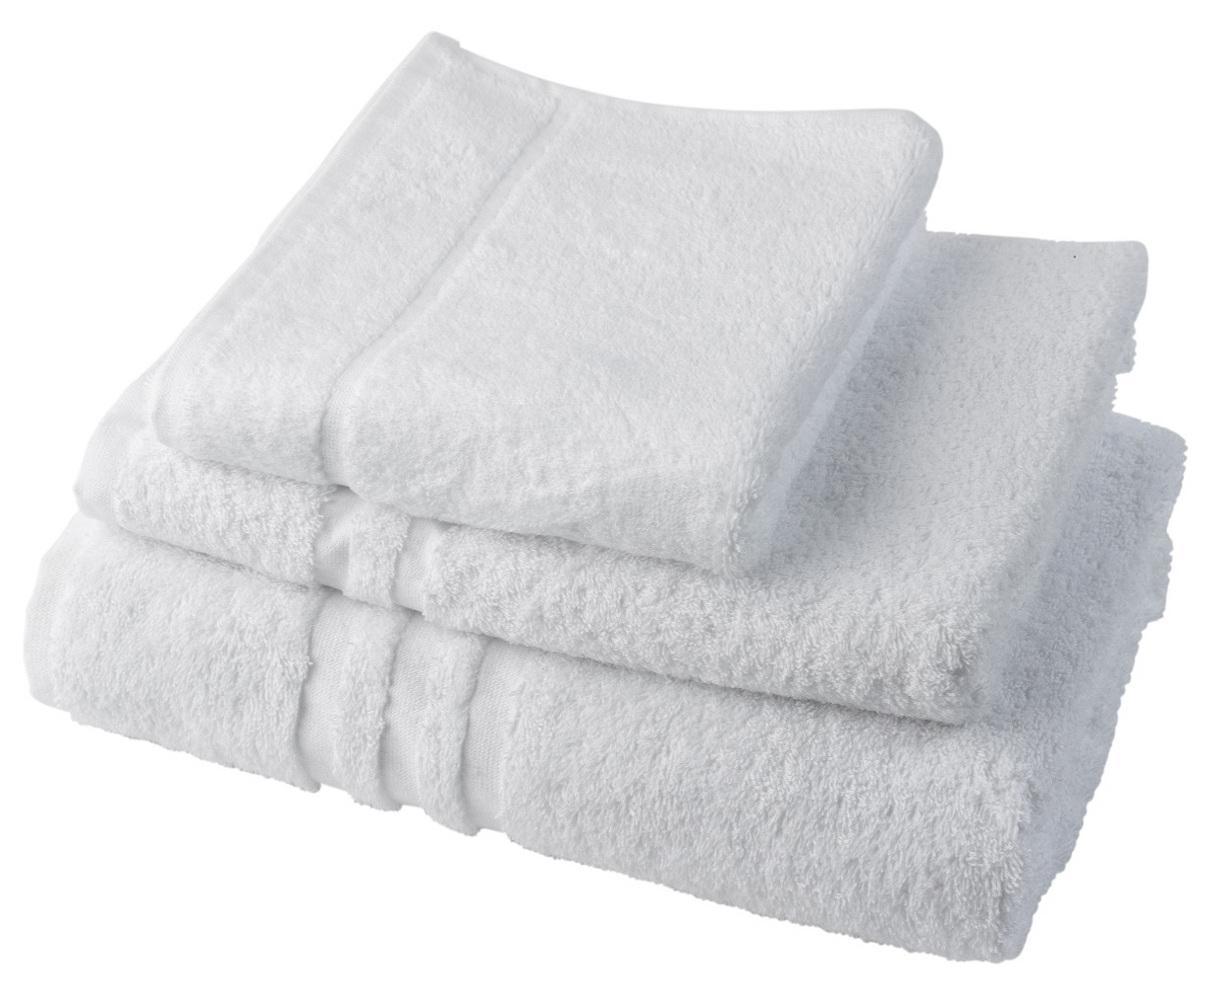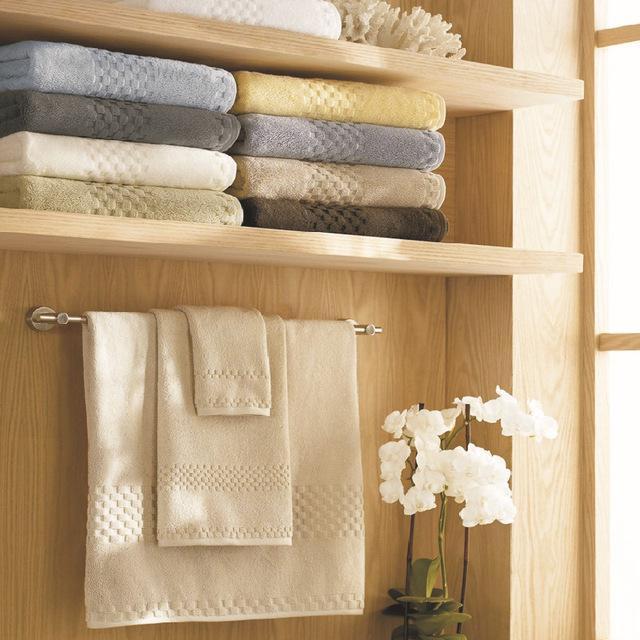The first image is the image on the left, the second image is the image on the right. Evaluate the accuracy of this statement regarding the images: "IN at least one image there is a tower of six folded towels.". Is it true? Answer yes or no. No. The first image is the image on the left, the second image is the image on the right. Assess this claim about the two images: "In one image, six towels the same color are folded and stacked according to size, smallest on top.". Correct or not? Answer yes or no. No. 